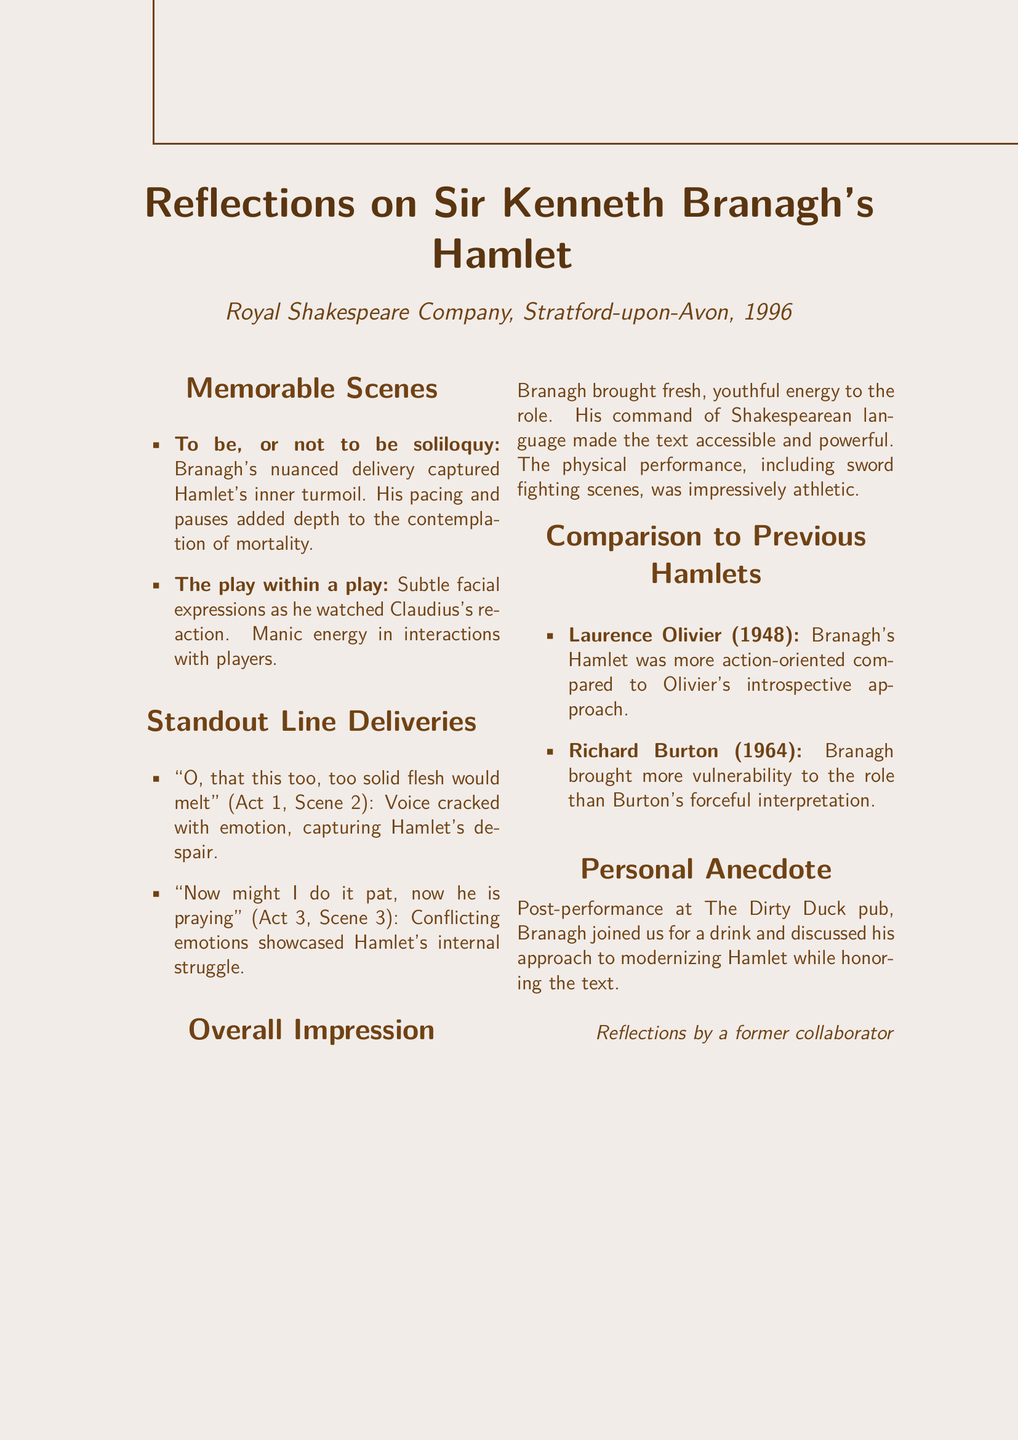What year did Branagh perform Hamlet? The document states that Branagh's performance was in 1996.
Answer: 1996 What notable soliloquy is highlighted in the memo? The memo specifically mentions the "To be, or not to be soliloquy."
Answer: To be, or not to be soliloquy Who directed the performance at the Royal Shakespeare Company? The document does not provide the director's name, focusing instead on Branagh's performance.
Answer: Not specified Which scene is described with the line "The play's the thing"? This line is associated with the "play within a play" scene.
Answer: The play within a play How did Branagh's portrayal compare to Laurence Olivier's Hamlet? The document notes that Branagh's Hamlet was more action-oriented compared to Olivier's introspective approach.
Answer: More action-oriented What was Branagh's emotional delivery during the line about solid flesh? The document mentions that Branagh's voice cracked with emotion.
Answer: Voice cracked with emotion Where did the personal anecdote take place? The document states that the discussion occurred at The Dirty Duck pub.
Answer: The Dirty Duck pub In what way did Branagh's performance bring new energy to the role? The memo indicates that Branagh brought a fresh, youthful energy to the role, contrasting with previous interpretations.
Answer: Fresh, youthful energy What was Branagh's take on modernizing Hamlet according to the personal anecdote? The anecdote reflects that he discussed modernizing Hamlet while honoring the text.
Answer: Modernizing Hamlet while honoring the text 